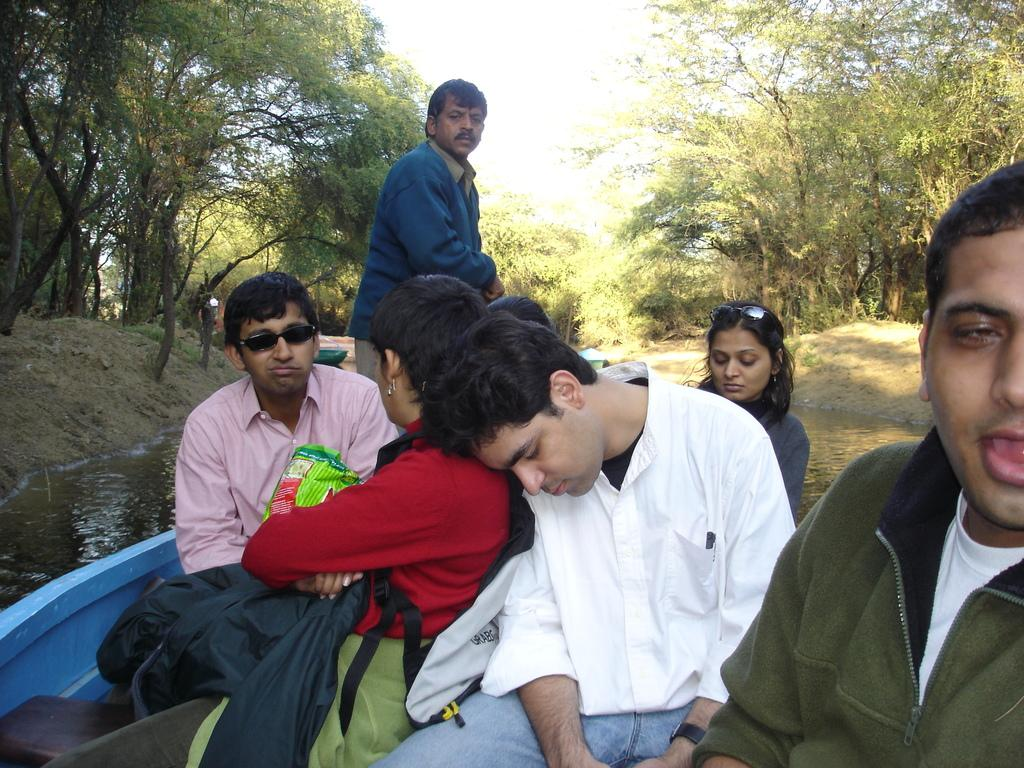What is happening on the water in the image? There are boats on the water in the image. Who or what is in the boats? There are people in the boats. What can be seen in the background of the image? There are trees visible in the background of the image. What type of reward is being given to the bucket in the image? There is no bucket present in the image, so it is not possible to determine if a reward is being given. 